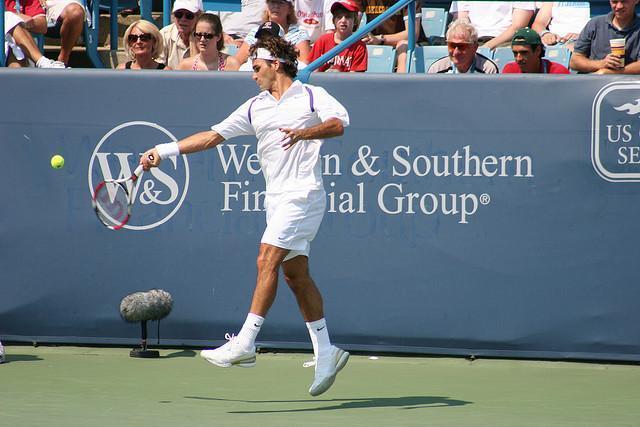How many people are visible?
Give a very brief answer. 7. 